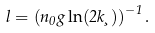Convert formula to latex. <formula><loc_0><loc_0><loc_500><loc_500>l = \left ( n _ { 0 } g \ln ( 2 k \xi ) \right ) ^ { - 1 } .</formula> 